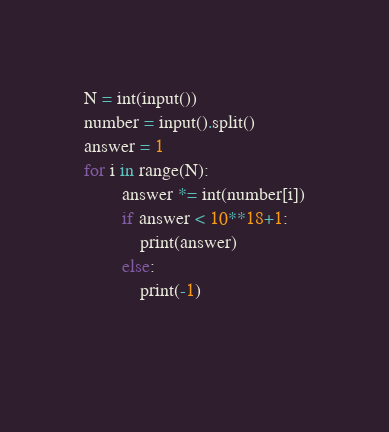Convert code to text. <code><loc_0><loc_0><loc_500><loc_500><_Python_>N = int(input())
number = input().split()
answer = 1
for i in range(N):
        answer *= int(number[i])
        if answer < 10**18+1:
            print(answer)
        else:
            print(-1)

            </code> 